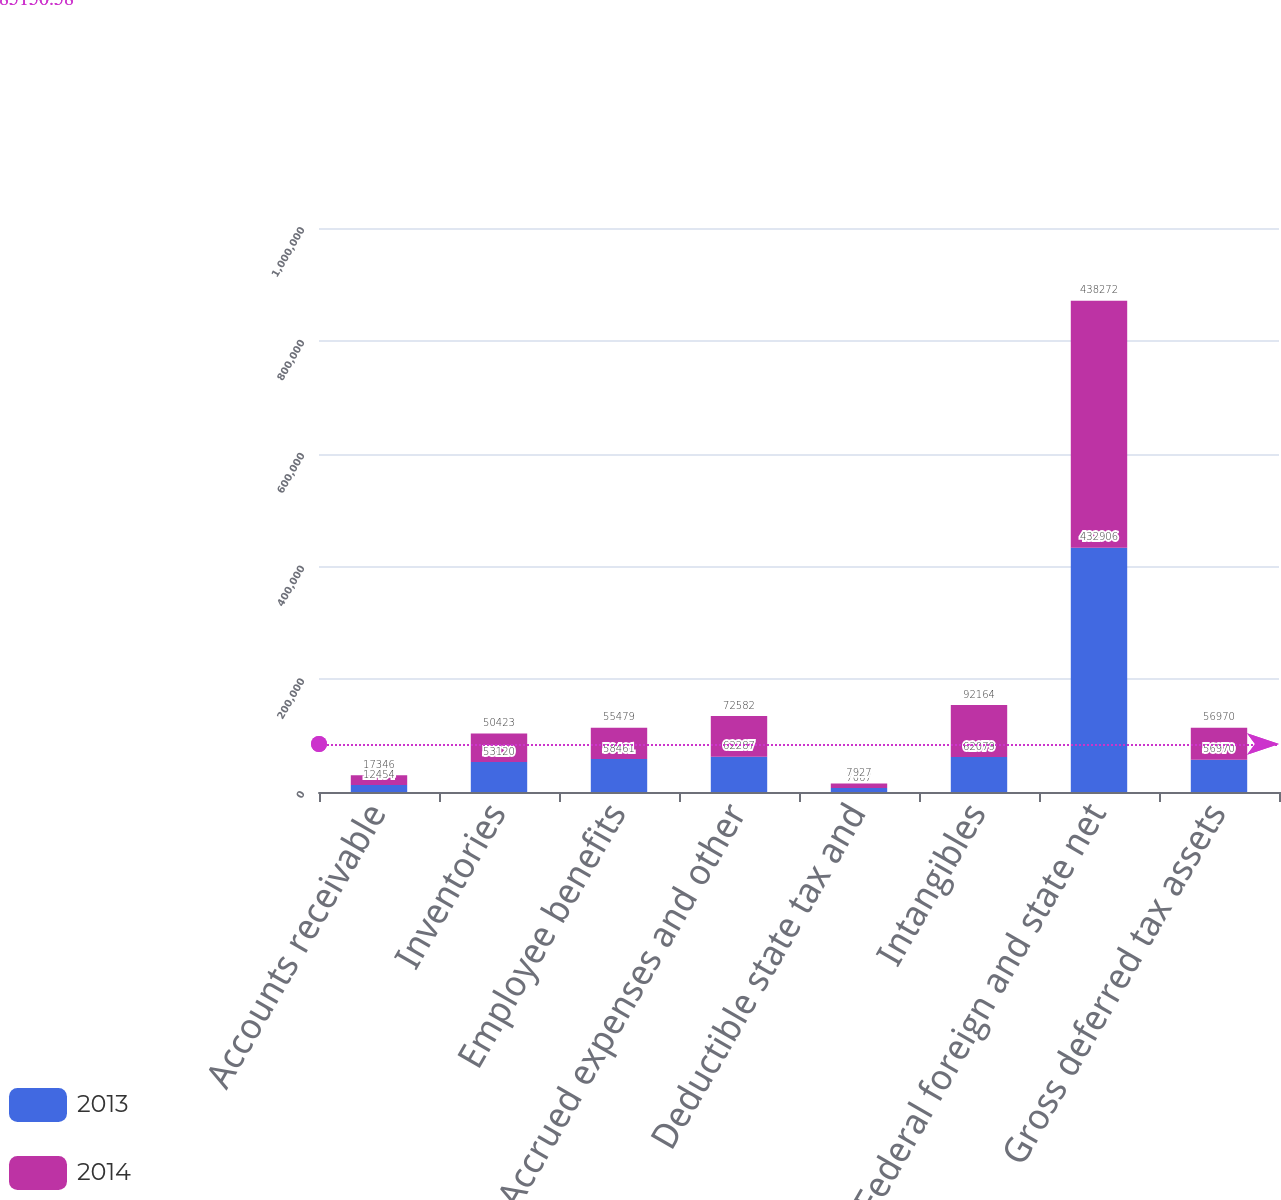Convert chart to OTSL. <chart><loc_0><loc_0><loc_500><loc_500><stacked_bar_chart><ecel><fcel>Accounts receivable<fcel>Inventories<fcel>Employee benefits<fcel>Accrued expenses and other<fcel>Deductible state tax and<fcel>Intangibles<fcel>Federal foreign and state net<fcel>Gross deferred tax assets<nl><fcel>2013<fcel>12454<fcel>53120<fcel>58461<fcel>62287<fcel>7067<fcel>62079<fcel>432906<fcel>56970<nl><fcel>2014<fcel>17346<fcel>50423<fcel>55479<fcel>72582<fcel>7927<fcel>92164<fcel>438272<fcel>56970<nl></chart> 